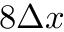Convert formula to latex. <formula><loc_0><loc_0><loc_500><loc_500>8 \Delta x</formula> 